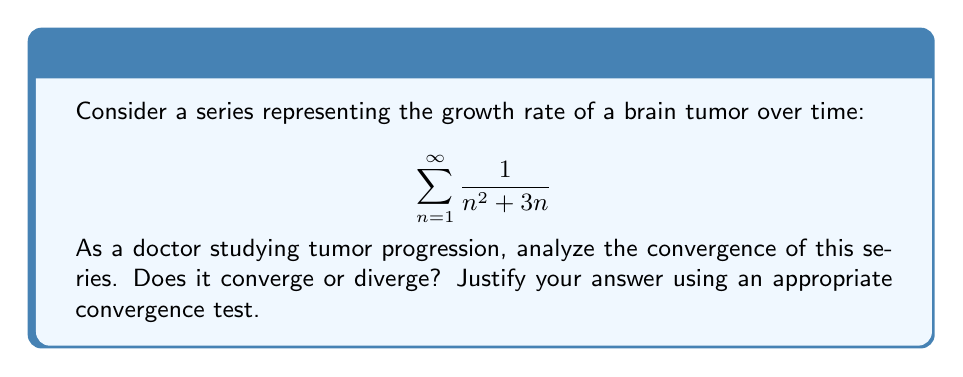Teach me how to tackle this problem. To analyze the convergence of this series, we can use the comparison test. Let's approach this step-by-step:

1) First, let's examine the general term of the series:

   $$a_n = \frac{1}{n^2 + 3n}$$

2) We can factor the denominator:

   $$a_n = \frac{1}{n(n + 3)}$$

3) For large $n$, we can see that $n(n+3) > n^2$. Therefore:

   $$\frac{1}{n(n+3)} < \frac{1}{n^2}$$

4) This means our series is bounded above by the p-series $\sum_{n=1}^{\infty} \frac{1}{n^2}$.

5) We know that the p-series $\sum_{n=1}^{\infty} \frac{1}{n^p}$ converges for $p > 1$.

6) In this case, $p = 2 > 1$, so $\sum_{n=1}^{\infty} \frac{1}{n^2}$ converges.

7) By the comparison test, if $\sum_{n=1}^{\infty} \frac{1}{n^2}$ converges, then our original series $\sum_{n=1}^{\infty} \frac{1}{n^2 + 3n}$ must also converge.

From a medical perspective, this convergence suggests that the tumor growth rate diminishes over time, potentially reaching a plateau. This could be due to factors such as limited resources or the body's immune response.
Answer: The series $\sum_{n=1}^{\infty} \frac{1}{n^2 + 3n}$ converges. 